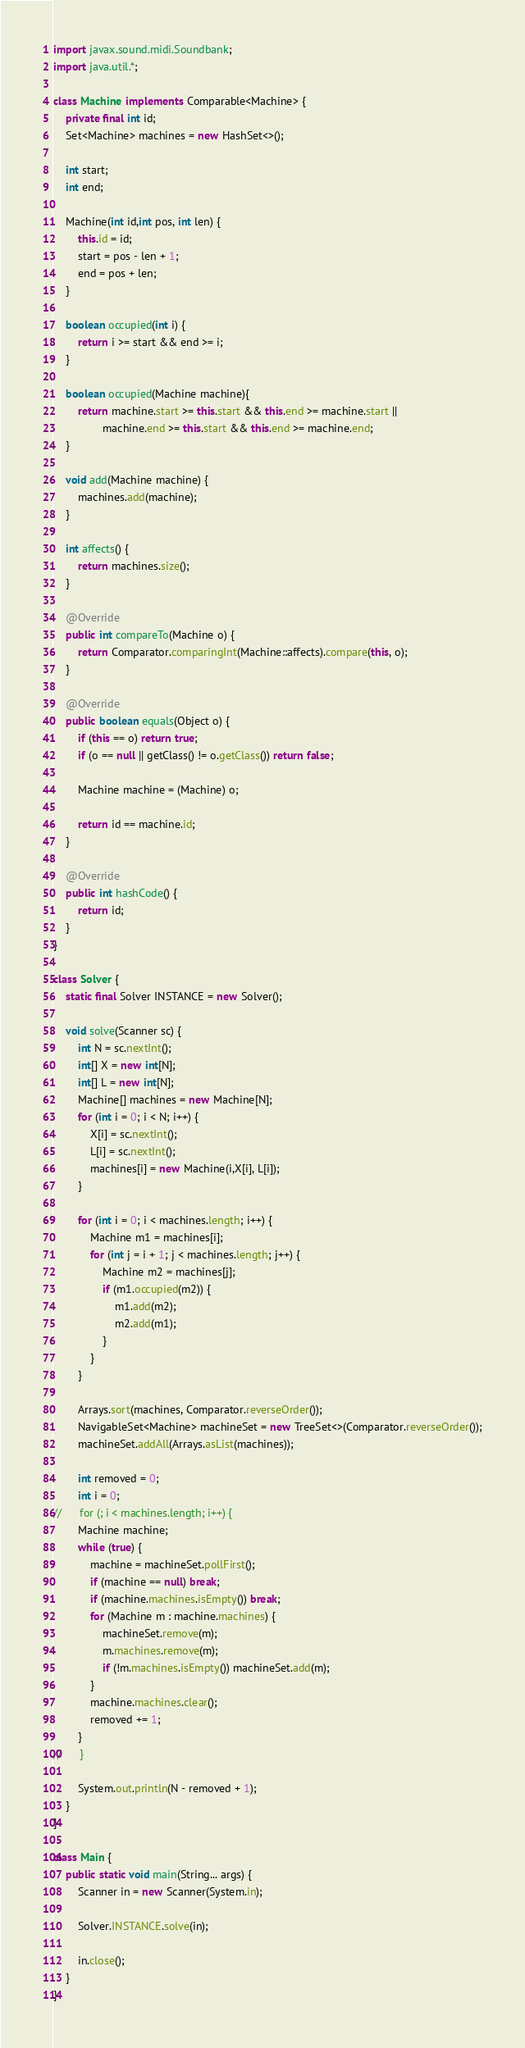<code> <loc_0><loc_0><loc_500><loc_500><_Java_>import javax.sound.midi.Soundbank;
import java.util.*;

class Machine implements Comparable<Machine> {
	private final int id;
	Set<Machine> machines = new HashSet<>();

	int start;
	int end;

	Machine(int id,int pos, int len) {
		this.id = id;
		start = pos - len + 1;
		end = pos + len;
	}

	boolean occupied(int i) {
		return i >= start && end >= i;
	}

	boolean occupied(Machine machine){
		return machine.start >= this.start && this.end >= machine.start ||
				machine.end >= this.start && this.end >= machine.end;
	}

	void add(Machine machine) {
		machines.add(machine);
	}

	int affects() {
		return machines.size();
	}

	@Override
	public int compareTo(Machine o) {
		return Comparator.comparingInt(Machine::affects).compare(this, o);
	}

	@Override
	public boolean equals(Object o) {
		if (this == o) return true;
		if (o == null || getClass() != o.getClass()) return false;

		Machine machine = (Machine) o;

		return id == machine.id;
	}

	@Override
	public int hashCode() {
		return id;
	}
}

class Solver {
	static final Solver INSTANCE = new Solver();

	void solve(Scanner sc) {
		int N = sc.nextInt();
		int[] X = new int[N];
		int[] L = new int[N];
		Machine[] machines = new Machine[N];
		for (int i = 0; i < N; i++) {
			X[i] = sc.nextInt();
			L[i] = sc.nextInt();
			machines[i] = new Machine(i,X[i], L[i]);
		}

		for (int i = 0; i < machines.length; i++) {
			Machine m1 = machines[i];
			for (int j = i + 1; j < machines.length; j++) {
				Machine m2 = machines[j];
				if (m1.occupied(m2)) {
					m1.add(m2);
					m2.add(m1);
				}
			}
		}

		Arrays.sort(machines, Comparator.reverseOrder());
		NavigableSet<Machine> machineSet = new TreeSet<>(Comparator.reverseOrder());
		machineSet.addAll(Arrays.asList(machines));

		int removed = 0;
		int i = 0;
//		for (; i < machines.length; i++) {
		Machine machine;
		while (true) {
			machine = machineSet.pollFirst();
			if (machine == null) break;
			if (machine.machines.isEmpty()) break;
			for (Machine m : machine.machines) {
				machineSet.remove(m);
				m.machines.remove(m);
				if (!m.machines.isEmpty()) machineSet.add(m);
			}
			machine.machines.clear();
			removed += 1;
		}
//		}

		System.out.println(N - removed + 1);
	}
}

class Main {
	public static void main(String... args) {
		Scanner in = new Scanner(System.in);

		Solver.INSTANCE.solve(in);

		in.close();
	}
}</code> 